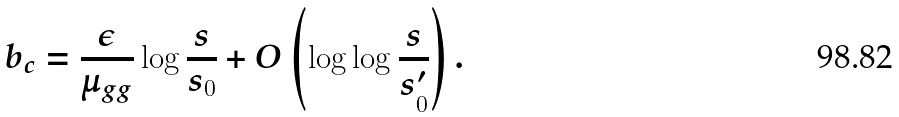<formula> <loc_0><loc_0><loc_500><loc_500>b _ { c } = \frac { \epsilon } { \mu _ { g g } } \log \frac { s } { s _ { 0 } } + O \left ( \log \log \frac { s } { s ^ { \prime } _ { 0 } } \right ) .</formula> 